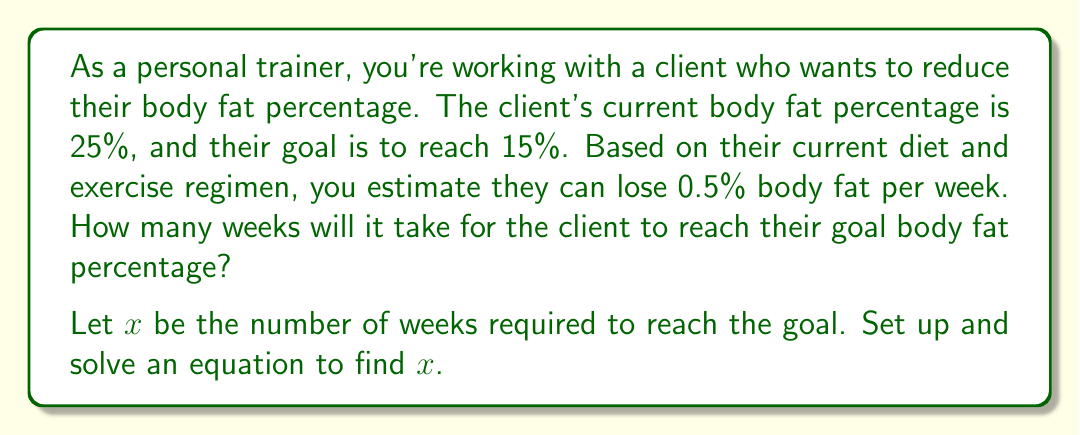Show me your answer to this math problem. To solve this problem, we need to set up an equation based on the given information:

1. Current body fat percentage: 25%
2. Goal body fat percentage: 15%
3. Rate of body fat loss: 0.5% per week

Let's set up the equation:

$$ 25 - 0.5x = 15 $$

Where $x$ represents the number of weeks.

Now, let's solve the equation:

1. Subtract 25 from both sides:
   $$ -0.5x = -10 $$

2. Divide both sides by -0.5:
   $$ x = \frac{-10}{-0.5} = 20 $$

Therefore, it will take 20 weeks for the client to reach their goal body fat percentage.

To verify:
Initial body fat: 25%
Weekly loss: 0.5% × 20 weeks = 10%
Final body fat: 25% - 10% = 15%
Answer: $x = 20$ weeks 